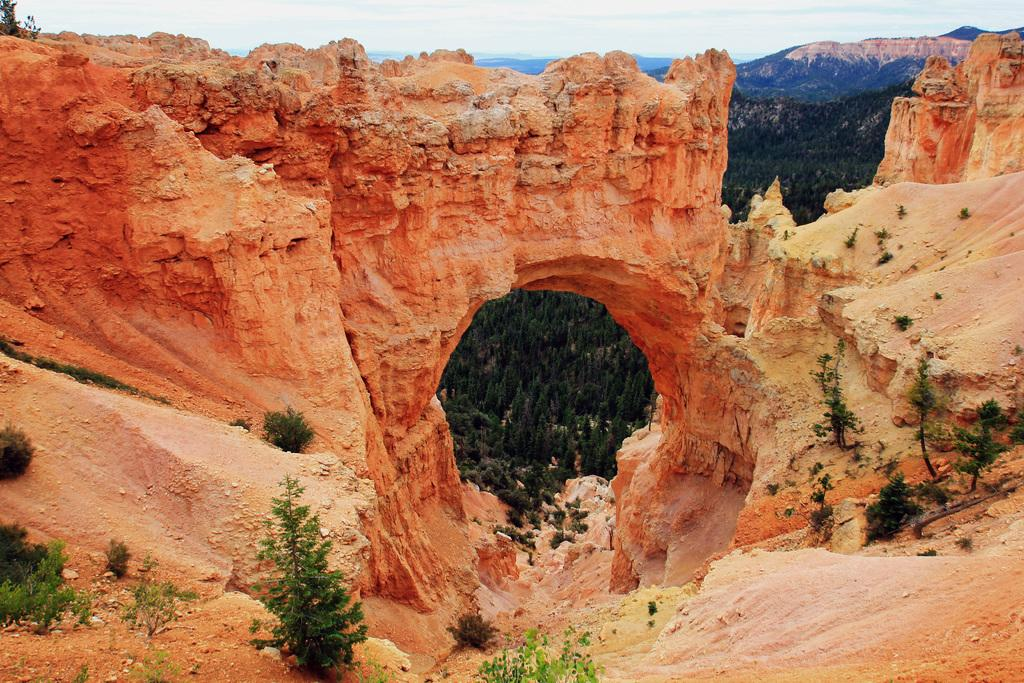What is the main subject of the image? The main subject of the image is the many plants. What geographical feature can be seen in the front of the image? There appears to be a mountain in the front of the image. What part of the natural environment is visible in the background of the image? The sky is visible in the background of the image. How many snakes are crawling on the plants in the image? There are no snakes present in the image; it features plants and a mountain. 